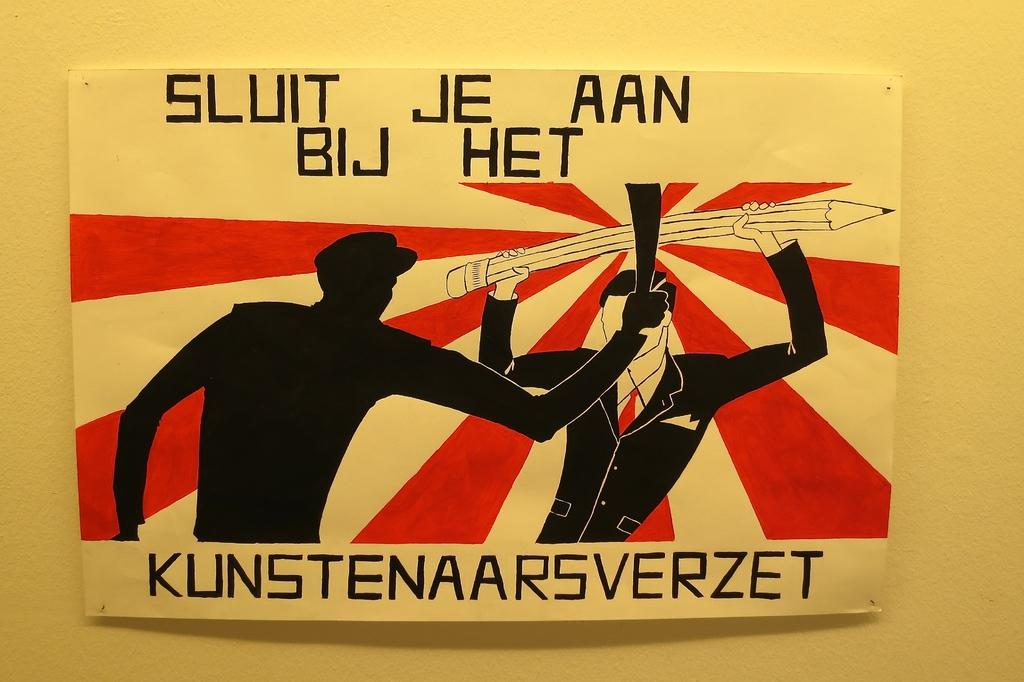<image>
Render a clear and concise summary of the photo. Drawing of a man using a pencil to block an attack and the words " Sluit Je Aan Bij Het". 